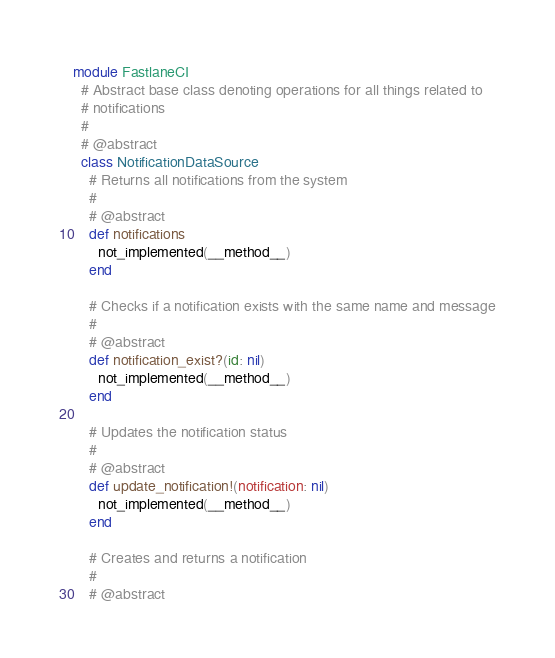<code> <loc_0><loc_0><loc_500><loc_500><_Ruby_>module FastlaneCI
  # Abstract base class denoting operations for all things related to
  # notifications
  #
  # @abstract
  class NotificationDataSource
    # Returns all notifications from the system
    #
    # @abstract
    def notifications
      not_implemented(__method__)
    end

    # Checks if a notification exists with the same name and message
    #
    # @abstract
    def notification_exist?(id: nil)
      not_implemented(__method__)
    end

    # Updates the notification status
    #
    # @abstract
    def update_notification!(notification: nil)
      not_implemented(__method__)
    end

    # Creates and returns a notification
    #
    # @abstract</code> 